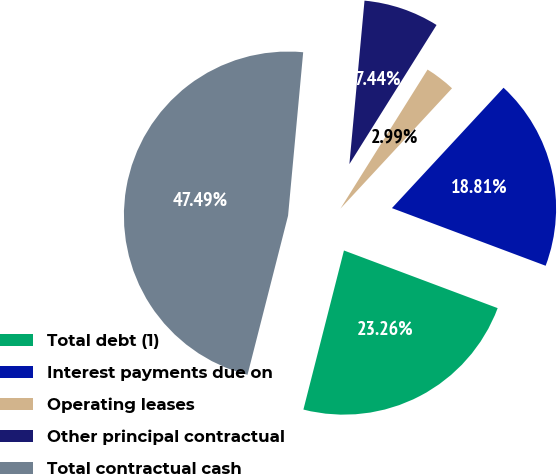<chart> <loc_0><loc_0><loc_500><loc_500><pie_chart><fcel>Total debt (1)<fcel>Interest payments due on<fcel>Operating leases<fcel>Other principal contractual<fcel>Total contractual cash<nl><fcel>23.26%<fcel>18.81%<fcel>2.99%<fcel>7.44%<fcel>47.49%<nl></chart> 